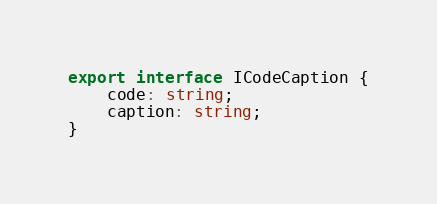<code> <loc_0><loc_0><loc_500><loc_500><_TypeScript_>export interface ICodeCaption {
    code: string;
    caption: string;
}
</code> 